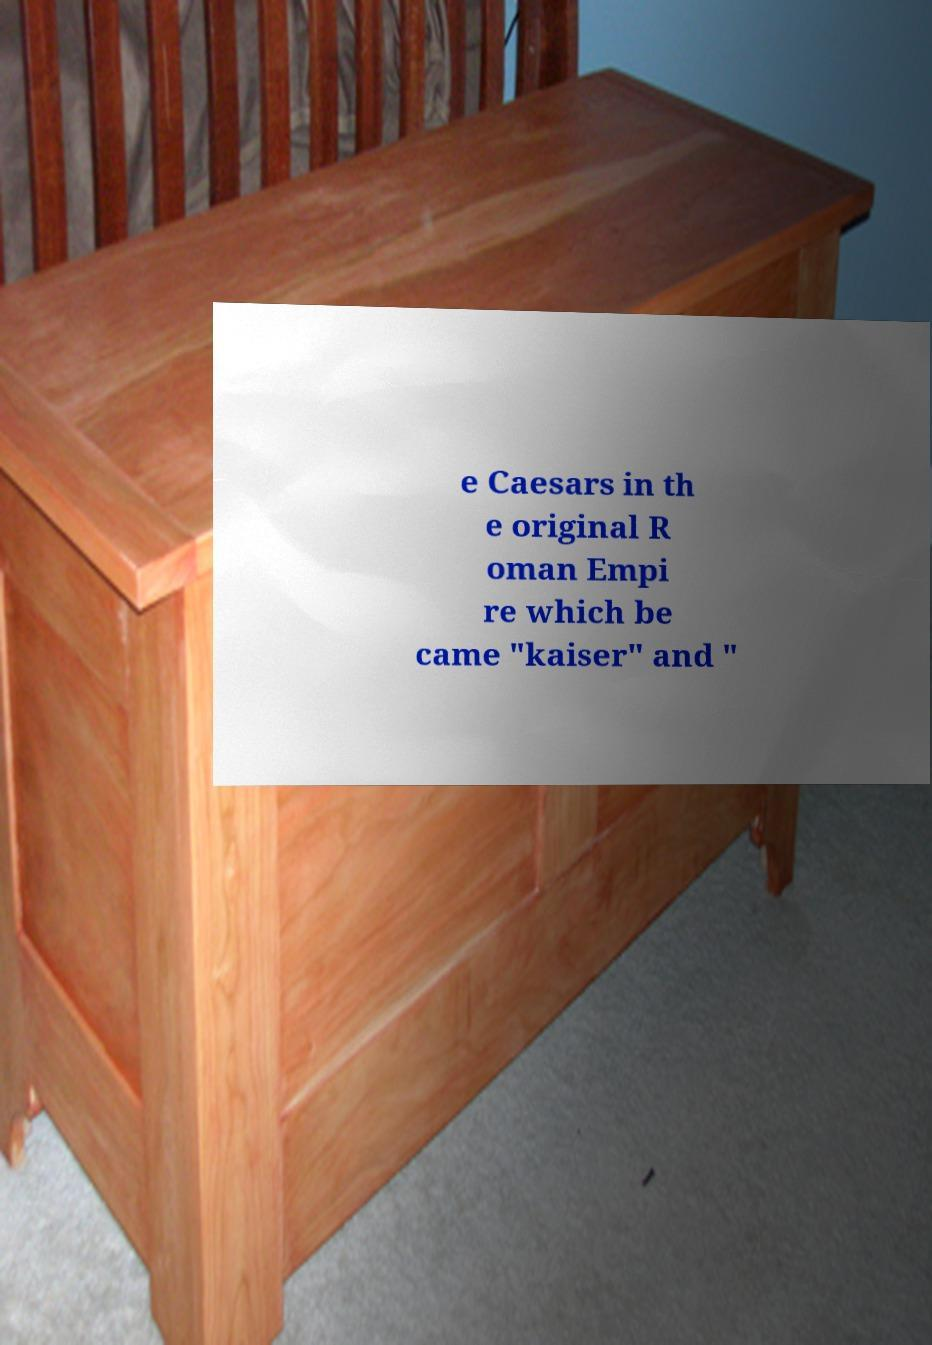Please identify and transcribe the text found in this image. e Caesars in th e original R oman Empi re which be came "kaiser" and " 